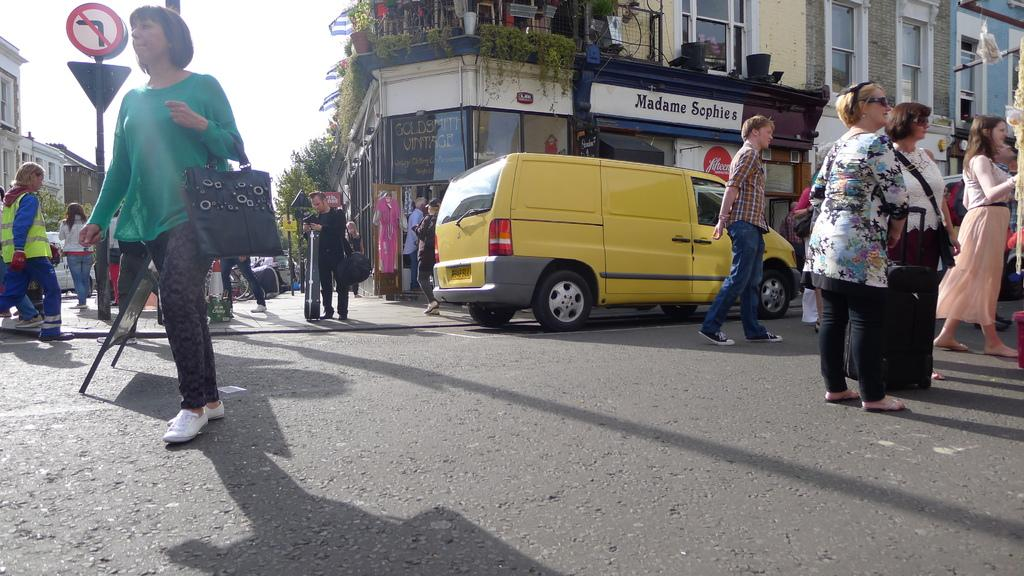What type of location is shown in the image? The image depicts a busy street. How many people can be seen on the street? There are many people on the street. What else is present on the street besides people? There are vehicles present. What can be seen in the background of the image? There are buildings, hoardings, and trees visible in the background. What might be used for displaying information or advertisements in the image? There is a sign board in the image. How many chairs are visible in the image? There are no chairs visible in the image. What type of fruit is being exchanged between the people on the street? There is no fruit or exchange of any kind visible in the image. 